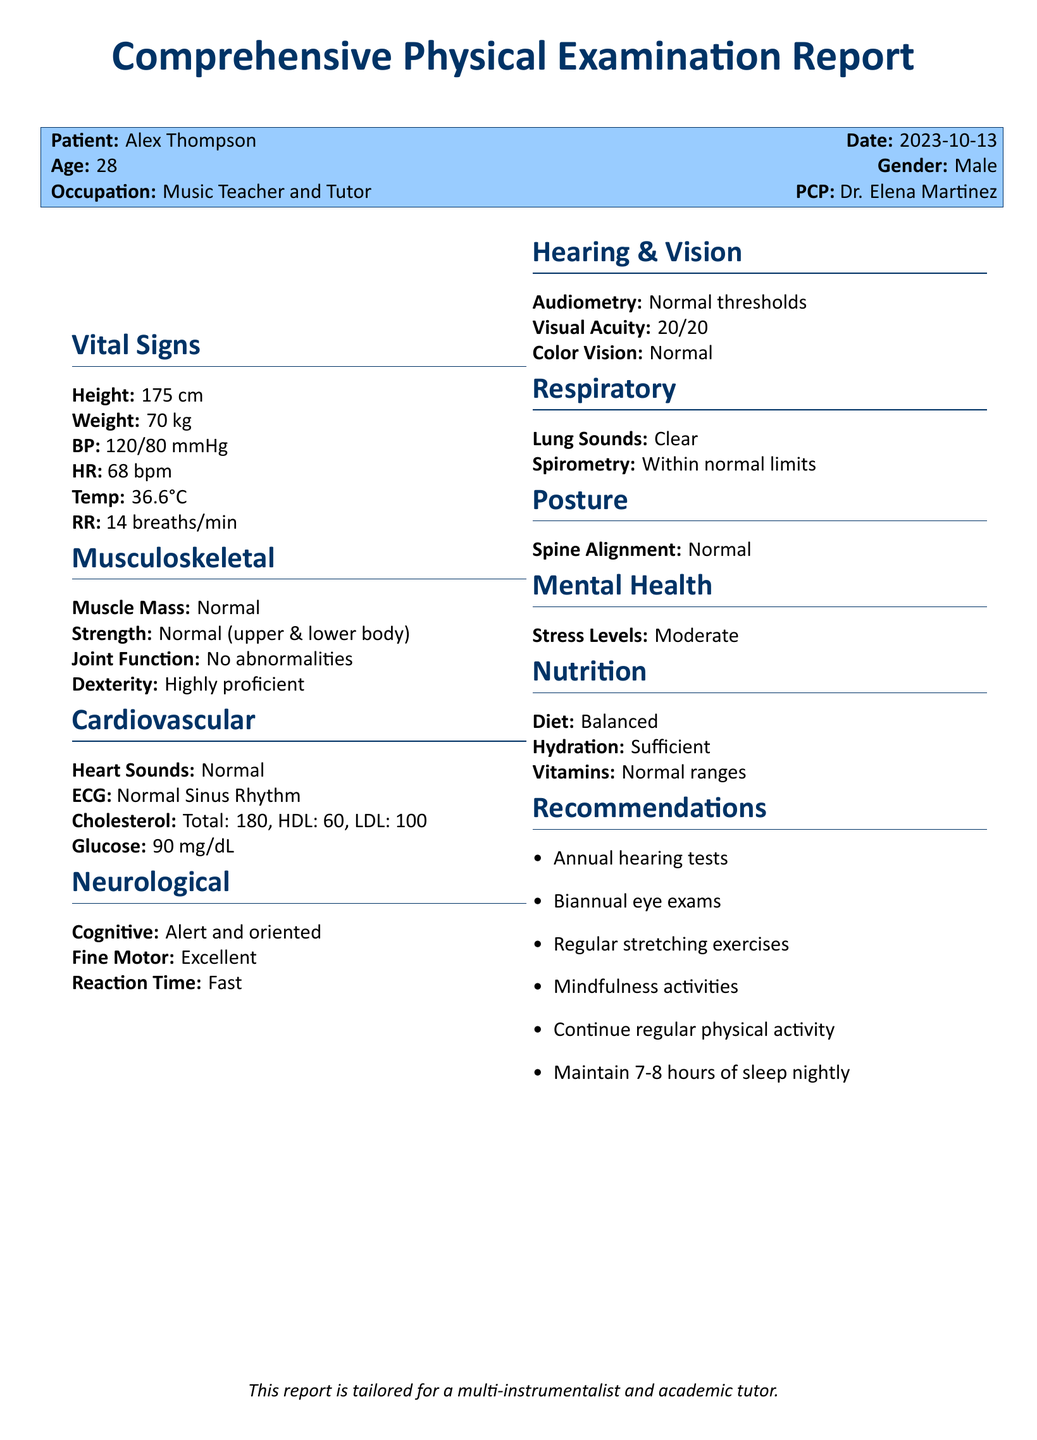What is the patient's name? The patient's name is stated at the beginning of the report.
Answer: Alex Thompson What is the date of the examination? The date of the examination is included with the patient's information.
Answer: 2023-10-13 What is the patient's height? The height of the patient is listed in the Vital Signs section of the report.
Answer: 175 cm What are the cholesterol levels? The cholesterol levels, including total, HDL, and LDL, can be found in the Cardiovascular section.
Answer: Total: 180, HDL: 60, LDL: 100 What is the patient's heart rate? The heart rate is noted in the Vital Signs section of the document.
Answer: 68 bpm What is the recommendation for hearing tests? The recommendations section suggests specific actions to maintain health.
Answer: Annual hearing tests What is the normal range for vitamins? The vitamin status is included in the Nutrition section of the report.
Answer: Normal ranges What does the mental health assessment report regarding stress levels? The mental health section indicates the assessment of the patient's well-being.
Answer: Moderate What is the patient's occupation? The occupation is listed in the initial patient information block.
Answer: Music Teacher and Tutor 